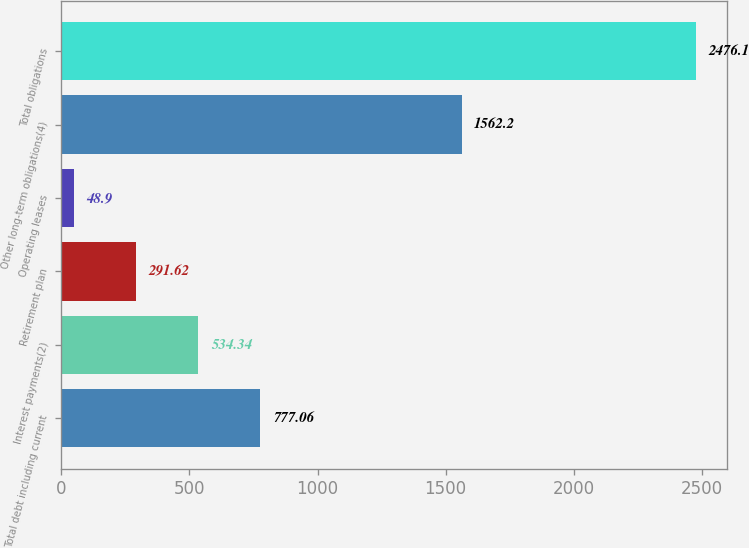Convert chart. <chart><loc_0><loc_0><loc_500><loc_500><bar_chart><fcel>Total debt including current<fcel>Interest payments(2)<fcel>Retirement plan<fcel>Operating leases<fcel>Other long-term obligations(4)<fcel>Total obligations<nl><fcel>777.06<fcel>534.34<fcel>291.62<fcel>48.9<fcel>1562.2<fcel>2476.1<nl></chart> 